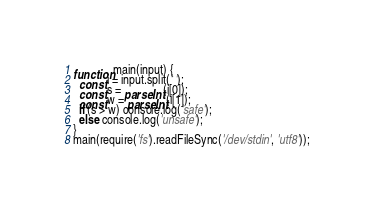Convert code to text. <code><loc_0><loc_0><loc_500><loc_500><_JavaScript_>function main(input) {
  const i = input.split(' ');
  const s = parseInt(i[0]);
  const w = parseInt(i[1]);
  if (s > w) console.log('safe');
  else console.log('unsafe');
}
main(require('fs').readFileSync('/dev/stdin', 'utf8'));</code> 